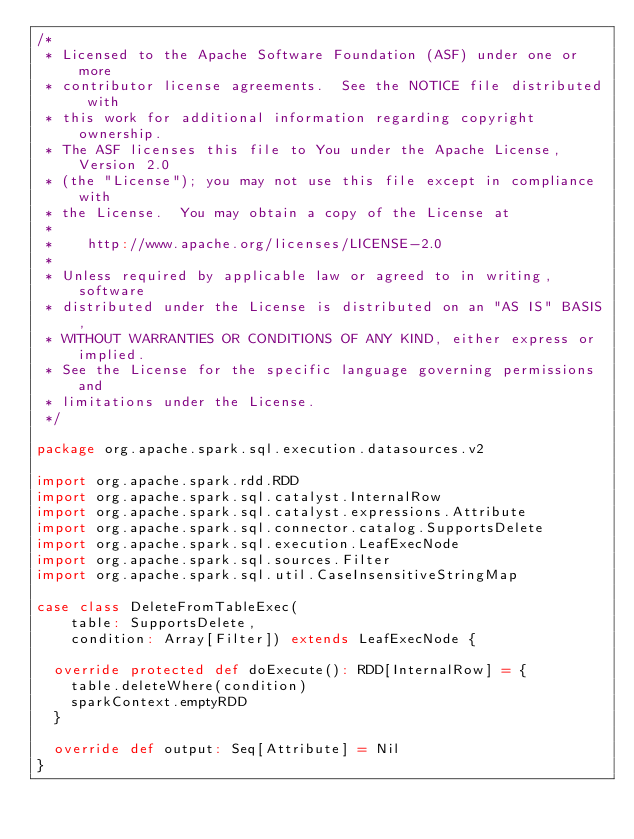<code> <loc_0><loc_0><loc_500><loc_500><_Scala_>/*
 * Licensed to the Apache Software Foundation (ASF) under one or more
 * contributor license agreements.  See the NOTICE file distributed with
 * this work for additional information regarding copyright ownership.
 * The ASF licenses this file to You under the Apache License, Version 2.0
 * (the "License"); you may not use this file except in compliance with
 * the License.  You may obtain a copy of the License at
 *
 *    http://www.apache.org/licenses/LICENSE-2.0
 *
 * Unless required by applicable law or agreed to in writing, software
 * distributed under the License is distributed on an "AS IS" BASIS,
 * WITHOUT WARRANTIES OR CONDITIONS OF ANY KIND, either express or implied.
 * See the License for the specific language governing permissions and
 * limitations under the License.
 */

package org.apache.spark.sql.execution.datasources.v2

import org.apache.spark.rdd.RDD
import org.apache.spark.sql.catalyst.InternalRow
import org.apache.spark.sql.catalyst.expressions.Attribute
import org.apache.spark.sql.connector.catalog.SupportsDelete
import org.apache.spark.sql.execution.LeafExecNode
import org.apache.spark.sql.sources.Filter
import org.apache.spark.sql.util.CaseInsensitiveStringMap

case class DeleteFromTableExec(
    table: SupportsDelete,
    condition: Array[Filter]) extends LeafExecNode {

  override protected def doExecute(): RDD[InternalRow] = {
    table.deleteWhere(condition)
    sparkContext.emptyRDD
  }

  override def output: Seq[Attribute] = Nil
}
</code> 